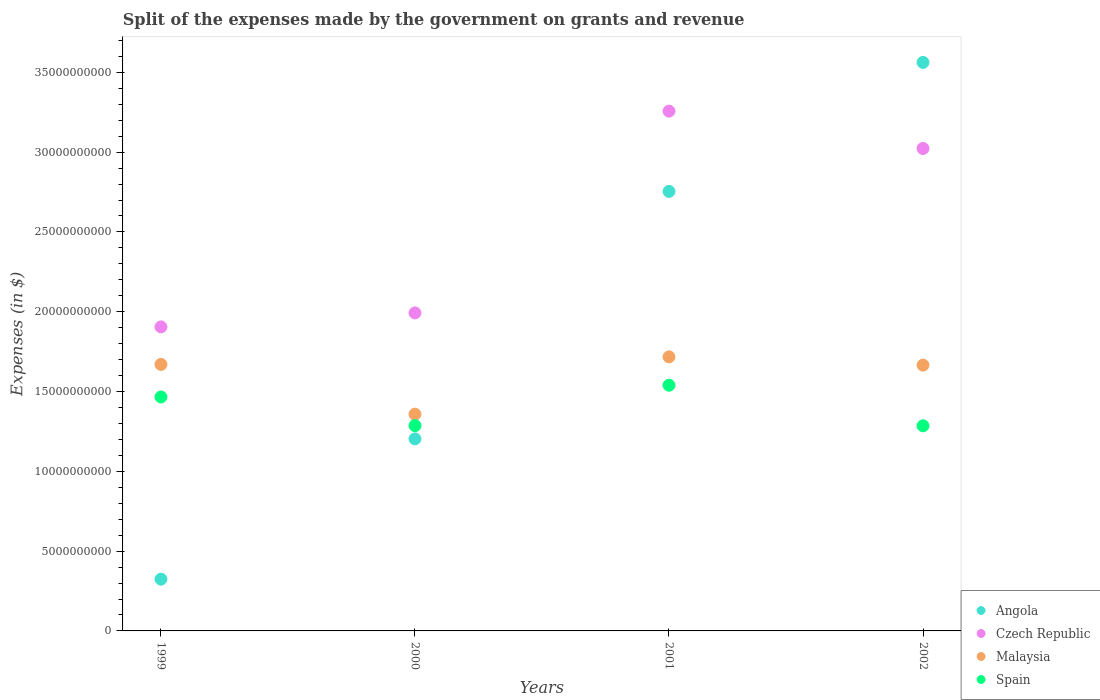How many different coloured dotlines are there?
Make the answer very short. 4. What is the expenses made by the government on grants and revenue in Angola in 2002?
Ensure brevity in your answer.  3.56e+1. Across all years, what is the maximum expenses made by the government on grants and revenue in Czech Republic?
Provide a short and direct response. 3.26e+1. Across all years, what is the minimum expenses made by the government on grants and revenue in Angola?
Offer a very short reply. 3.24e+09. In which year was the expenses made by the government on grants and revenue in Malaysia maximum?
Your response must be concise. 2001. What is the total expenses made by the government on grants and revenue in Czech Republic in the graph?
Make the answer very short. 1.02e+11. What is the difference between the expenses made by the government on grants and revenue in Spain in 1999 and that in 2002?
Ensure brevity in your answer.  1.81e+09. What is the difference between the expenses made by the government on grants and revenue in Malaysia in 2001 and the expenses made by the government on grants and revenue in Angola in 2000?
Your answer should be compact. 5.14e+09. What is the average expenses made by the government on grants and revenue in Spain per year?
Your answer should be very brief. 1.39e+1. In the year 2001, what is the difference between the expenses made by the government on grants and revenue in Czech Republic and expenses made by the government on grants and revenue in Angola?
Give a very brief answer. 5.03e+09. What is the ratio of the expenses made by the government on grants and revenue in Angola in 1999 to that in 2000?
Keep it short and to the point. 0.27. Is the expenses made by the government on grants and revenue in Angola in 2000 less than that in 2001?
Your answer should be compact. Yes. What is the difference between the highest and the second highest expenses made by the government on grants and revenue in Malaysia?
Provide a short and direct response. 4.75e+08. What is the difference between the highest and the lowest expenses made by the government on grants and revenue in Angola?
Your response must be concise. 3.24e+1. In how many years, is the expenses made by the government on grants and revenue in Angola greater than the average expenses made by the government on grants and revenue in Angola taken over all years?
Offer a terse response. 2. Is it the case that in every year, the sum of the expenses made by the government on grants and revenue in Czech Republic and expenses made by the government on grants and revenue in Spain  is greater than the sum of expenses made by the government on grants and revenue in Angola and expenses made by the government on grants and revenue in Malaysia?
Keep it short and to the point. No. Is it the case that in every year, the sum of the expenses made by the government on grants and revenue in Angola and expenses made by the government on grants and revenue in Malaysia  is greater than the expenses made by the government on grants and revenue in Czech Republic?
Your answer should be very brief. Yes. How many dotlines are there?
Your answer should be compact. 4. How many years are there in the graph?
Give a very brief answer. 4. What is the difference between two consecutive major ticks on the Y-axis?
Give a very brief answer. 5.00e+09. Are the values on the major ticks of Y-axis written in scientific E-notation?
Offer a terse response. No. Does the graph contain any zero values?
Offer a terse response. No. Does the graph contain grids?
Your answer should be compact. No. How many legend labels are there?
Offer a very short reply. 4. How are the legend labels stacked?
Ensure brevity in your answer.  Vertical. What is the title of the graph?
Provide a short and direct response. Split of the expenses made by the government on grants and revenue. What is the label or title of the X-axis?
Ensure brevity in your answer.  Years. What is the label or title of the Y-axis?
Offer a very short reply. Expenses (in $). What is the Expenses (in $) in Angola in 1999?
Keep it short and to the point. 3.24e+09. What is the Expenses (in $) in Czech Republic in 1999?
Provide a short and direct response. 1.91e+1. What is the Expenses (in $) of Malaysia in 1999?
Give a very brief answer. 1.67e+1. What is the Expenses (in $) of Spain in 1999?
Your answer should be very brief. 1.47e+1. What is the Expenses (in $) of Angola in 2000?
Make the answer very short. 1.20e+1. What is the Expenses (in $) of Czech Republic in 2000?
Make the answer very short. 1.99e+1. What is the Expenses (in $) in Malaysia in 2000?
Make the answer very short. 1.36e+1. What is the Expenses (in $) in Spain in 2000?
Make the answer very short. 1.29e+1. What is the Expenses (in $) in Angola in 2001?
Ensure brevity in your answer.  2.75e+1. What is the Expenses (in $) in Czech Republic in 2001?
Offer a terse response. 3.26e+1. What is the Expenses (in $) in Malaysia in 2001?
Offer a terse response. 1.72e+1. What is the Expenses (in $) of Spain in 2001?
Give a very brief answer. 1.54e+1. What is the Expenses (in $) of Angola in 2002?
Keep it short and to the point. 3.56e+1. What is the Expenses (in $) of Czech Republic in 2002?
Provide a succinct answer. 3.02e+1. What is the Expenses (in $) in Malaysia in 2002?
Ensure brevity in your answer.  1.67e+1. What is the Expenses (in $) of Spain in 2002?
Offer a very short reply. 1.29e+1. Across all years, what is the maximum Expenses (in $) of Angola?
Your answer should be compact. 3.56e+1. Across all years, what is the maximum Expenses (in $) of Czech Republic?
Provide a succinct answer. 3.26e+1. Across all years, what is the maximum Expenses (in $) in Malaysia?
Your response must be concise. 1.72e+1. Across all years, what is the maximum Expenses (in $) in Spain?
Provide a succinct answer. 1.54e+1. Across all years, what is the minimum Expenses (in $) in Angola?
Your response must be concise. 3.24e+09. Across all years, what is the minimum Expenses (in $) of Czech Republic?
Your answer should be very brief. 1.91e+1. Across all years, what is the minimum Expenses (in $) in Malaysia?
Offer a terse response. 1.36e+1. Across all years, what is the minimum Expenses (in $) in Spain?
Your answer should be compact. 1.29e+1. What is the total Expenses (in $) of Angola in the graph?
Make the answer very short. 7.84e+1. What is the total Expenses (in $) in Czech Republic in the graph?
Give a very brief answer. 1.02e+11. What is the total Expenses (in $) in Malaysia in the graph?
Keep it short and to the point. 6.41e+1. What is the total Expenses (in $) of Spain in the graph?
Your answer should be very brief. 5.58e+1. What is the difference between the Expenses (in $) in Angola in 1999 and that in 2000?
Provide a succinct answer. -8.79e+09. What is the difference between the Expenses (in $) in Czech Republic in 1999 and that in 2000?
Offer a very short reply. -8.76e+08. What is the difference between the Expenses (in $) in Malaysia in 1999 and that in 2000?
Your answer should be compact. 3.12e+09. What is the difference between the Expenses (in $) in Spain in 1999 and that in 2000?
Provide a short and direct response. 1.80e+09. What is the difference between the Expenses (in $) of Angola in 1999 and that in 2001?
Give a very brief answer. -2.43e+1. What is the difference between the Expenses (in $) in Czech Republic in 1999 and that in 2001?
Offer a very short reply. -1.35e+1. What is the difference between the Expenses (in $) in Malaysia in 1999 and that in 2001?
Your answer should be very brief. -4.75e+08. What is the difference between the Expenses (in $) of Spain in 1999 and that in 2001?
Your answer should be very brief. -7.36e+08. What is the difference between the Expenses (in $) in Angola in 1999 and that in 2002?
Keep it short and to the point. -3.24e+1. What is the difference between the Expenses (in $) of Czech Republic in 1999 and that in 2002?
Keep it short and to the point. -1.12e+1. What is the difference between the Expenses (in $) of Malaysia in 1999 and that in 2002?
Your answer should be compact. 4.43e+07. What is the difference between the Expenses (in $) in Spain in 1999 and that in 2002?
Provide a short and direct response. 1.81e+09. What is the difference between the Expenses (in $) in Angola in 2000 and that in 2001?
Offer a terse response. -1.55e+1. What is the difference between the Expenses (in $) of Czech Republic in 2000 and that in 2001?
Give a very brief answer. -1.26e+1. What is the difference between the Expenses (in $) of Malaysia in 2000 and that in 2001?
Offer a very short reply. -3.59e+09. What is the difference between the Expenses (in $) of Spain in 2000 and that in 2001?
Your answer should be compact. -2.53e+09. What is the difference between the Expenses (in $) of Angola in 2000 and that in 2002?
Offer a terse response. -2.36e+1. What is the difference between the Expenses (in $) of Czech Republic in 2000 and that in 2002?
Your response must be concise. -1.03e+1. What is the difference between the Expenses (in $) in Malaysia in 2000 and that in 2002?
Your answer should be compact. -3.07e+09. What is the difference between the Expenses (in $) in Angola in 2001 and that in 2002?
Ensure brevity in your answer.  -8.08e+09. What is the difference between the Expenses (in $) of Czech Republic in 2001 and that in 2002?
Provide a short and direct response. 2.34e+09. What is the difference between the Expenses (in $) of Malaysia in 2001 and that in 2002?
Provide a succinct answer. 5.19e+08. What is the difference between the Expenses (in $) in Spain in 2001 and that in 2002?
Keep it short and to the point. 2.54e+09. What is the difference between the Expenses (in $) of Angola in 1999 and the Expenses (in $) of Czech Republic in 2000?
Your response must be concise. -1.67e+1. What is the difference between the Expenses (in $) of Angola in 1999 and the Expenses (in $) of Malaysia in 2000?
Make the answer very short. -1.03e+1. What is the difference between the Expenses (in $) in Angola in 1999 and the Expenses (in $) in Spain in 2000?
Make the answer very short. -9.62e+09. What is the difference between the Expenses (in $) in Czech Republic in 1999 and the Expenses (in $) in Malaysia in 2000?
Ensure brevity in your answer.  5.47e+09. What is the difference between the Expenses (in $) in Czech Republic in 1999 and the Expenses (in $) in Spain in 2000?
Provide a succinct answer. 6.19e+09. What is the difference between the Expenses (in $) in Malaysia in 1999 and the Expenses (in $) in Spain in 2000?
Keep it short and to the point. 3.83e+09. What is the difference between the Expenses (in $) in Angola in 1999 and the Expenses (in $) in Czech Republic in 2001?
Provide a short and direct response. -2.93e+1. What is the difference between the Expenses (in $) in Angola in 1999 and the Expenses (in $) in Malaysia in 2001?
Offer a terse response. -1.39e+1. What is the difference between the Expenses (in $) in Angola in 1999 and the Expenses (in $) in Spain in 2001?
Keep it short and to the point. -1.22e+1. What is the difference between the Expenses (in $) in Czech Republic in 1999 and the Expenses (in $) in Malaysia in 2001?
Provide a succinct answer. 1.88e+09. What is the difference between the Expenses (in $) of Czech Republic in 1999 and the Expenses (in $) of Spain in 2001?
Offer a very short reply. 3.66e+09. What is the difference between the Expenses (in $) in Malaysia in 1999 and the Expenses (in $) in Spain in 2001?
Give a very brief answer. 1.30e+09. What is the difference between the Expenses (in $) of Angola in 1999 and the Expenses (in $) of Czech Republic in 2002?
Offer a terse response. -2.70e+1. What is the difference between the Expenses (in $) in Angola in 1999 and the Expenses (in $) in Malaysia in 2002?
Give a very brief answer. -1.34e+1. What is the difference between the Expenses (in $) in Angola in 1999 and the Expenses (in $) in Spain in 2002?
Offer a terse response. -9.61e+09. What is the difference between the Expenses (in $) in Czech Republic in 1999 and the Expenses (in $) in Malaysia in 2002?
Make the answer very short. 2.40e+09. What is the difference between the Expenses (in $) in Czech Republic in 1999 and the Expenses (in $) in Spain in 2002?
Give a very brief answer. 6.20e+09. What is the difference between the Expenses (in $) of Malaysia in 1999 and the Expenses (in $) of Spain in 2002?
Give a very brief answer. 3.85e+09. What is the difference between the Expenses (in $) of Angola in 2000 and the Expenses (in $) of Czech Republic in 2001?
Ensure brevity in your answer.  -2.05e+1. What is the difference between the Expenses (in $) in Angola in 2000 and the Expenses (in $) in Malaysia in 2001?
Offer a very short reply. -5.14e+09. What is the difference between the Expenses (in $) of Angola in 2000 and the Expenses (in $) of Spain in 2001?
Give a very brief answer. -3.36e+09. What is the difference between the Expenses (in $) in Czech Republic in 2000 and the Expenses (in $) in Malaysia in 2001?
Keep it short and to the point. 2.75e+09. What is the difference between the Expenses (in $) in Czech Republic in 2000 and the Expenses (in $) in Spain in 2001?
Keep it short and to the point. 4.53e+09. What is the difference between the Expenses (in $) of Malaysia in 2000 and the Expenses (in $) of Spain in 2001?
Give a very brief answer. -1.81e+09. What is the difference between the Expenses (in $) of Angola in 2000 and the Expenses (in $) of Czech Republic in 2002?
Ensure brevity in your answer.  -1.82e+1. What is the difference between the Expenses (in $) of Angola in 2000 and the Expenses (in $) of Malaysia in 2002?
Your answer should be compact. -4.62e+09. What is the difference between the Expenses (in $) in Angola in 2000 and the Expenses (in $) in Spain in 2002?
Offer a very short reply. -8.19e+08. What is the difference between the Expenses (in $) in Czech Republic in 2000 and the Expenses (in $) in Malaysia in 2002?
Your answer should be very brief. 3.27e+09. What is the difference between the Expenses (in $) in Czech Republic in 2000 and the Expenses (in $) in Spain in 2002?
Ensure brevity in your answer.  7.07e+09. What is the difference between the Expenses (in $) of Malaysia in 2000 and the Expenses (in $) of Spain in 2002?
Ensure brevity in your answer.  7.29e+08. What is the difference between the Expenses (in $) in Angola in 2001 and the Expenses (in $) in Czech Republic in 2002?
Provide a short and direct response. -2.69e+09. What is the difference between the Expenses (in $) of Angola in 2001 and the Expenses (in $) of Malaysia in 2002?
Offer a terse response. 1.09e+1. What is the difference between the Expenses (in $) of Angola in 2001 and the Expenses (in $) of Spain in 2002?
Ensure brevity in your answer.  1.47e+1. What is the difference between the Expenses (in $) in Czech Republic in 2001 and the Expenses (in $) in Malaysia in 2002?
Ensure brevity in your answer.  1.59e+1. What is the difference between the Expenses (in $) in Czech Republic in 2001 and the Expenses (in $) in Spain in 2002?
Offer a terse response. 1.97e+1. What is the difference between the Expenses (in $) in Malaysia in 2001 and the Expenses (in $) in Spain in 2002?
Your response must be concise. 4.32e+09. What is the average Expenses (in $) in Angola per year?
Make the answer very short. 1.96e+1. What is the average Expenses (in $) in Czech Republic per year?
Keep it short and to the point. 2.54e+1. What is the average Expenses (in $) of Malaysia per year?
Keep it short and to the point. 1.60e+1. What is the average Expenses (in $) in Spain per year?
Give a very brief answer. 1.39e+1. In the year 1999, what is the difference between the Expenses (in $) of Angola and Expenses (in $) of Czech Republic?
Offer a terse response. -1.58e+1. In the year 1999, what is the difference between the Expenses (in $) in Angola and Expenses (in $) in Malaysia?
Make the answer very short. -1.35e+1. In the year 1999, what is the difference between the Expenses (in $) of Angola and Expenses (in $) of Spain?
Provide a short and direct response. -1.14e+1. In the year 1999, what is the difference between the Expenses (in $) in Czech Republic and Expenses (in $) in Malaysia?
Keep it short and to the point. 2.35e+09. In the year 1999, what is the difference between the Expenses (in $) in Czech Republic and Expenses (in $) in Spain?
Provide a short and direct response. 4.39e+09. In the year 1999, what is the difference between the Expenses (in $) in Malaysia and Expenses (in $) in Spain?
Provide a succinct answer. 2.04e+09. In the year 2000, what is the difference between the Expenses (in $) of Angola and Expenses (in $) of Czech Republic?
Make the answer very short. -7.89e+09. In the year 2000, what is the difference between the Expenses (in $) of Angola and Expenses (in $) of Malaysia?
Your answer should be compact. -1.55e+09. In the year 2000, what is the difference between the Expenses (in $) in Angola and Expenses (in $) in Spain?
Keep it short and to the point. -8.31e+08. In the year 2000, what is the difference between the Expenses (in $) of Czech Republic and Expenses (in $) of Malaysia?
Provide a succinct answer. 6.34e+09. In the year 2000, what is the difference between the Expenses (in $) of Czech Republic and Expenses (in $) of Spain?
Give a very brief answer. 7.06e+09. In the year 2000, what is the difference between the Expenses (in $) in Malaysia and Expenses (in $) in Spain?
Ensure brevity in your answer.  7.17e+08. In the year 2001, what is the difference between the Expenses (in $) in Angola and Expenses (in $) in Czech Republic?
Your response must be concise. -5.03e+09. In the year 2001, what is the difference between the Expenses (in $) of Angola and Expenses (in $) of Malaysia?
Offer a very short reply. 1.04e+1. In the year 2001, what is the difference between the Expenses (in $) in Angola and Expenses (in $) in Spain?
Offer a terse response. 1.21e+1. In the year 2001, what is the difference between the Expenses (in $) of Czech Republic and Expenses (in $) of Malaysia?
Provide a short and direct response. 1.54e+1. In the year 2001, what is the difference between the Expenses (in $) of Czech Republic and Expenses (in $) of Spain?
Provide a short and direct response. 1.72e+1. In the year 2001, what is the difference between the Expenses (in $) in Malaysia and Expenses (in $) in Spain?
Provide a short and direct response. 1.78e+09. In the year 2002, what is the difference between the Expenses (in $) of Angola and Expenses (in $) of Czech Republic?
Make the answer very short. 5.39e+09. In the year 2002, what is the difference between the Expenses (in $) in Angola and Expenses (in $) in Malaysia?
Your answer should be very brief. 1.90e+1. In the year 2002, what is the difference between the Expenses (in $) of Angola and Expenses (in $) of Spain?
Give a very brief answer. 2.28e+1. In the year 2002, what is the difference between the Expenses (in $) of Czech Republic and Expenses (in $) of Malaysia?
Provide a short and direct response. 1.36e+1. In the year 2002, what is the difference between the Expenses (in $) in Czech Republic and Expenses (in $) in Spain?
Provide a succinct answer. 1.74e+1. In the year 2002, what is the difference between the Expenses (in $) of Malaysia and Expenses (in $) of Spain?
Ensure brevity in your answer.  3.80e+09. What is the ratio of the Expenses (in $) in Angola in 1999 to that in 2000?
Ensure brevity in your answer.  0.27. What is the ratio of the Expenses (in $) in Czech Republic in 1999 to that in 2000?
Offer a very short reply. 0.96. What is the ratio of the Expenses (in $) of Malaysia in 1999 to that in 2000?
Provide a short and direct response. 1.23. What is the ratio of the Expenses (in $) in Spain in 1999 to that in 2000?
Make the answer very short. 1.14. What is the ratio of the Expenses (in $) in Angola in 1999 to that in 2001?
Offer a very short reply. 0.12. What is the ratio of the Expenses (in $) of Czech Republic in 1999 to that in 2001?
Your response must be concise. 0.58. What is the ratio of the Expenses (in $) of Malaysia in 1999 to that in 2001?
Provide a short and direct response. 0.97. What is the ratio of the Expenses (in $) of Spain in 1999 to that in 2001?
Provide a succinct answer. 0.95. What is the ratio of the Expenses (in $) in Angola in 1999 to that in 2002?
Your answer should be compact. 0.09. What is the ratio of the Expenses (in $) of Czech Republic in 1999 to that in 2002?
Give a very brief answer. 0.63. What is the ratio of the Expenses (in $) of Spain in 1999 to that in 2002?
Provide a short and direct response. 1.14. What is the ratio of the Expenses (in $) in Angola in 2000 to that in 2001?
Provide a succinct answer. 0.44. What is the ratio of the Expenses (in $) of Czech Republic in 2000 to that in 2001?
Offer a very short reply. 0.61. What is the ratio of the Expenses (in $) of Malaysia in 2000 to that in 2001?
Your response must be concise. 0.79. What is the ratio of the Expenses (in $) of Spain in 2000 to that in 2001?
Offer a terse response. 0.84. What is the ratio of the Expenses (in $) of Angola in 2000 to that in 2002?
Your answer should be very brief. 0.34. What is the ratio of the Expenses (in $) of Czech Republic in 2000 to that in 2002?
Provide a short and direct response. 0.66. What is the ratio of the Expenses (in $) of Malaysia in 2000 to that in 2002?
Ensure brevity in your answer.  0.82. What is the ratio of the Expenses (in $) in Angola in 2001 to that in 2002?
Your response must be concise. 0.77. What is the ratio of the Expenses (in $) in Czech Republic in 2001 to that in 2002?
Your answer should be very brief. 1.08. What is the ratio of the Expenses (in $) in Malaysia in 2001 to that in 2002?
Your answer should be compact. 1.03. What is the ratio of the Expenses (in $) in Spain in 2001 to that in 2002?
Provide a succinct answer. 1.2. What is the difference between the highest and the second highest Expenses (in $) of Angola?
Your answer should be very brief. 8.08e+09. What is the difference between the highest and the second highest Expenses (in $) in Czech Republic?
Keep it short and to the point. 2.34e+09. What is the difference between the highest and the second highest Expenses (in $) in Malaysia?
Make the answer very short. 4.75e+08. What is the difference between the highest and the second highest Expenses (in $) in Spain?
Offer a terse response. 7.36e+08. What is the difference between the highest and the lowest Expenses (in $) of Angola?
Provide a succinct answer. 3.24e+1. What is the difference between the highest and the lowest Expenses (in $) in Czech Republic?
Keep it short and to the point. 1.35e+1. What is the difference between the highest and the lowest Expenses (in $) of Malaysia?
Make the answer very short. 3.59e+09. What is the difference between the highest and the lowest Expenses (in $) of Spain?
Provide a succinct answer. 2.54e+09. 